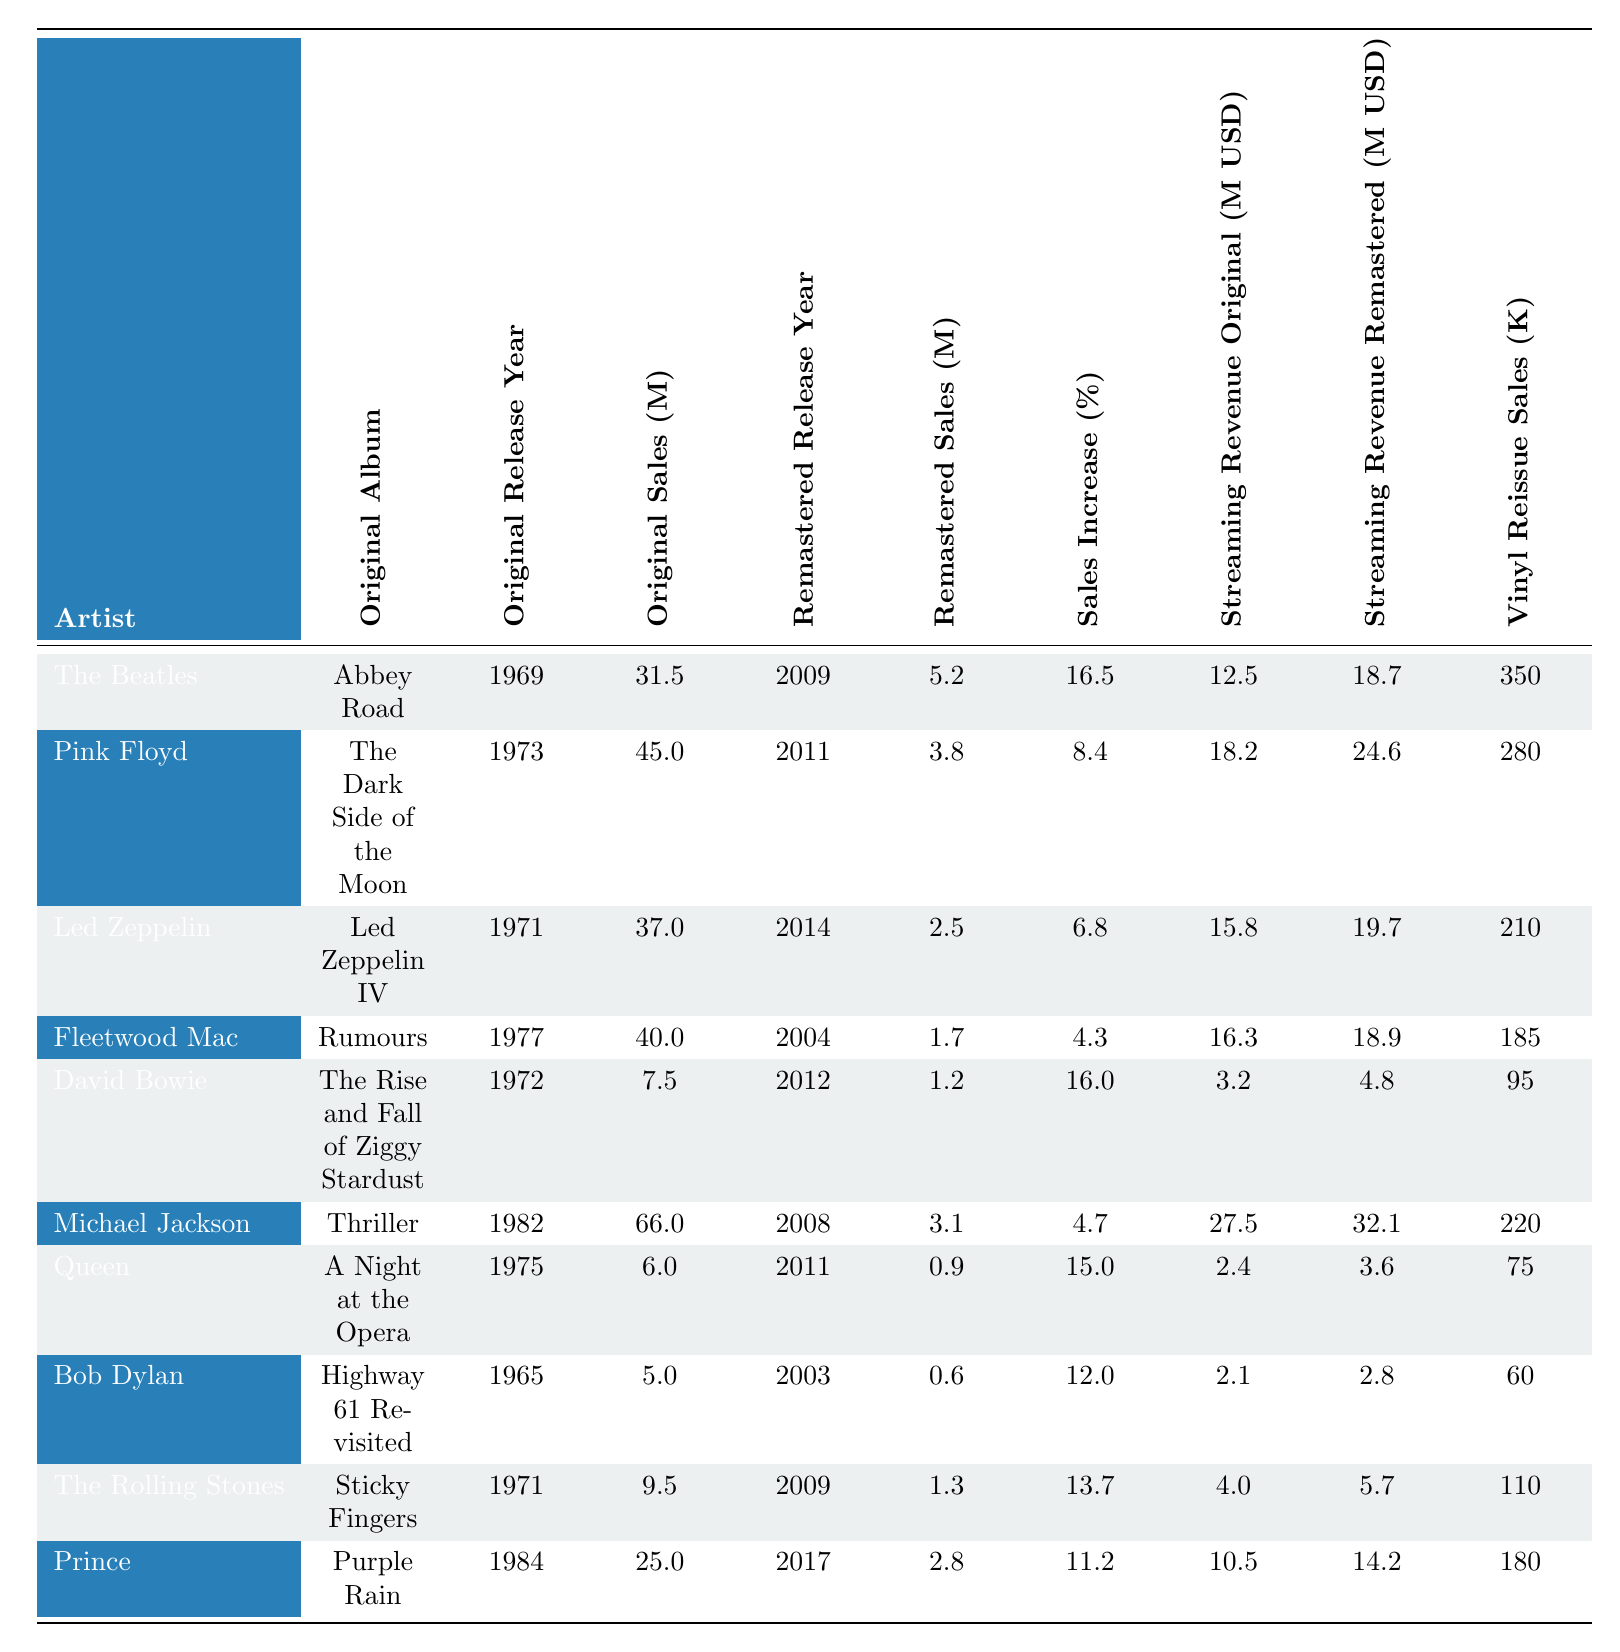What is the highest original album sales among the artists listed? The original sales data shows that Michael Jackson's "Thriller" has the highest sales at 66 million.
Answer: 66 million Which artist had the lowest remastered album sales? In the remastered sales data, Queen's "A Night at the Opera" has the lowest sales at 0.9 million.
Answer: 0.9 million What is the sales increase percentage for Fleetwood Mac's album? Fleetwood Mac has a sales increase of 4.3%, as indicated in the sales increase percentage column.
Answer: 4.3% Which album was remastered first and how many millions did it sell? "Abbey Road" by The Beatles was remastered in 2009 and sold 5.2 million.
Answer: 5.2 million What are the total original sales for all artists listed? Summing all the original sales values: 31.5 + 45.0 + 37.0 + 40.0 + 7.5 + 66.0 + 6.0 + 5.0 + 9.5 + 25.0 = 272.5 million.
Answer: 272.5 million Which artist experienced the greatest percentage increase in sales from original to remastered? The highest sales increase percentage is 16.5% for The Beatles' "Abbey Road."
Answer: 16.5% What is the difference in streaming revenue between original and remastered for Michael Jackson? The original streaming revenue is 27.5 million and the remastered is 32.1 million. The difference is 32.1 - 27.5 = 4.6 million.
Answer: 4.6 million How does the vinyl reissue sales of Pink Floyd compare to that of Fleetwood Mac? Pink Floyd sold 280 thousand records while Fleetwood Mac sold 185 thousand records, so Pink Floyd sold 95 thousand more.
Answer: 95 thousand more Is it true that all artists had higher streaming revenue from remastered albums compared to original albums? No, Queen, Bob Dylan, and Fleetwood Mac had lower remastered streaming revenue compared to original revenue.
Answer: No What is the average remastered sales across all artists? Total remastered sales is 5.2 + 3.8 + 2.5 + 1.7 + 1.2 + 3.1 + 0.9 + 0.6 + 1.3 + 2.8 = 23.1 million. Average is 23.1 / 10 = 2.31 million.
Answer: 2.31 million 